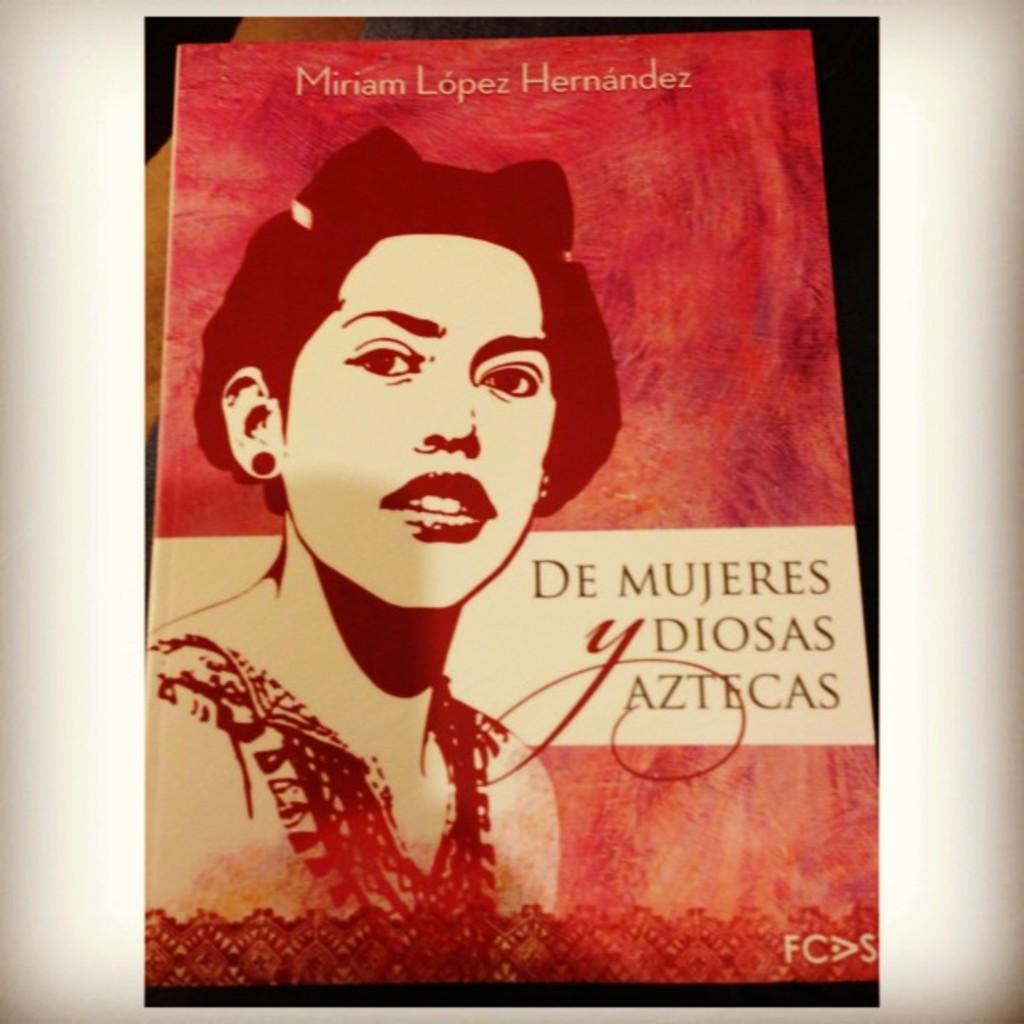Could you give a brief overview of what you see in this image? In this image, we can see depiction of a person and some text. 